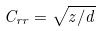Convert formula to latex. <formula><loc_0><loc_0><loc_500><loc_500>C _ { r r } = \sqrt { z / d }</formula> 